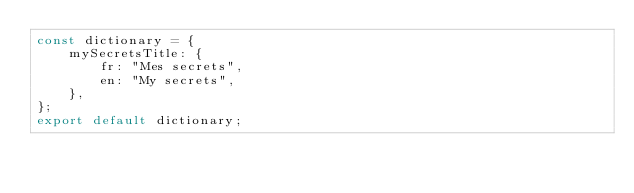<code> <loc_0><loc_0><loc_500><loc_500><_TypeScript_>const dictionary = {
    mySecretsTitle: {
        fr: "Mes secrets",
        en: "My secrets",
    },
};
export default dictionary;
</code> 